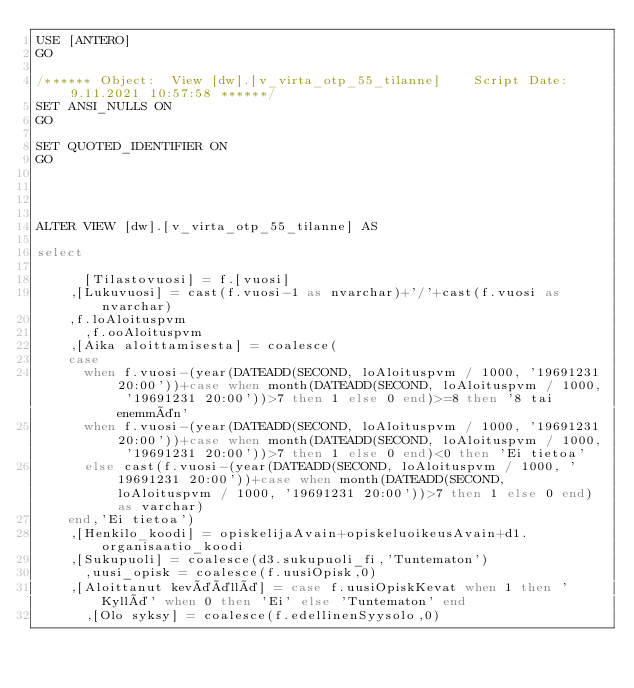<code> <loc_0><loc_0><loc_500><loc_500><_SQL_>USE [ANTERO]
GO

/****** Object:  View [dw].[v_virta_otp_55_tilanne]    Script Date: 9.11.2021 10:57:58 ******/
SET ANSI_NULLS ON
GO

SET QUOTED_IDENTIFIER ON
GO




ALTER VIEW [dw].[v_virta_otp_55_tilanne] AS

select 
      
      [Tilastovuosi] = f.[vuosi]
	  ,[Lukuvuosi] = cast(f.vuosi-1 as nvarchar)+'/'+cast(f.vuosi as nvarchar)
	  ,f.loAloituspvm
      ,f.ooAloituspvm
	  ,[Aika aloittamisesta] = coalesce(
		case 
			when f.vuosi-(year(DATEADD(SECOND, loAloituspvm / 1000, '19691231 20:00'))+case when month(DATEADD(SECOND, loAloituspvm / 1000, '19691231 20:00'))>7 then 1 else 0 end)>=8 then '8 tai enemmän' 
			when f.vuosi-(year(DATEADD(SECOND, loAloituspvm / 1000, '19691231 20:00'))+case when month(DATEADD(SECOND, loAloituspvm / 1000, '19691231 20:00'))>7 then 1 else 0 end)<0 then 'Ei tietoa'
			else cast(f.vuosi-(year(DATEADD(SECOND, loAloituspvm / 1000, '19691231 20:00'))+case when month(DATEADD(SECOND, loAloituspvm / 1000, '19691231 20:00'))>7 then 1 else 0 end) as varchar) 
		end,'Ei tietoa')
	  ,[Henkilo_koodi] = opiskelijaAvain+opiskeluoikeusAvain+d1.organisaatio_koodi
	  ,[Sukupuoli] = coalesce(d3.sukupuoli_fi,'Tuntematon')
      ,uusi_opisk = coalesce(f.uusiOpisk,0)
	  ,[Aloittanut keväällä] = case f.uusiOpiskKevat when 1 then 'Kyllä' when 0 then 'Ei' else 'Tuntematon' end
      ,[Olo syksy] = coalesce(f.edellinenSyysolo,0)</code> 